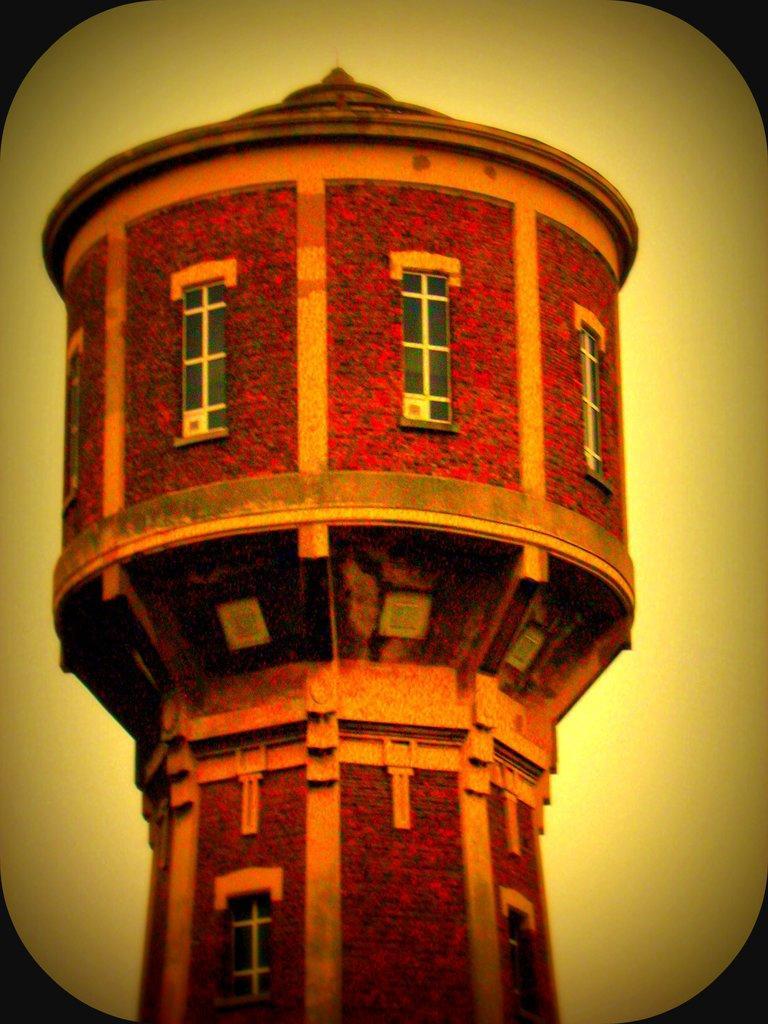Can you describe this image briefly? There is a building tower in the center of the image. 